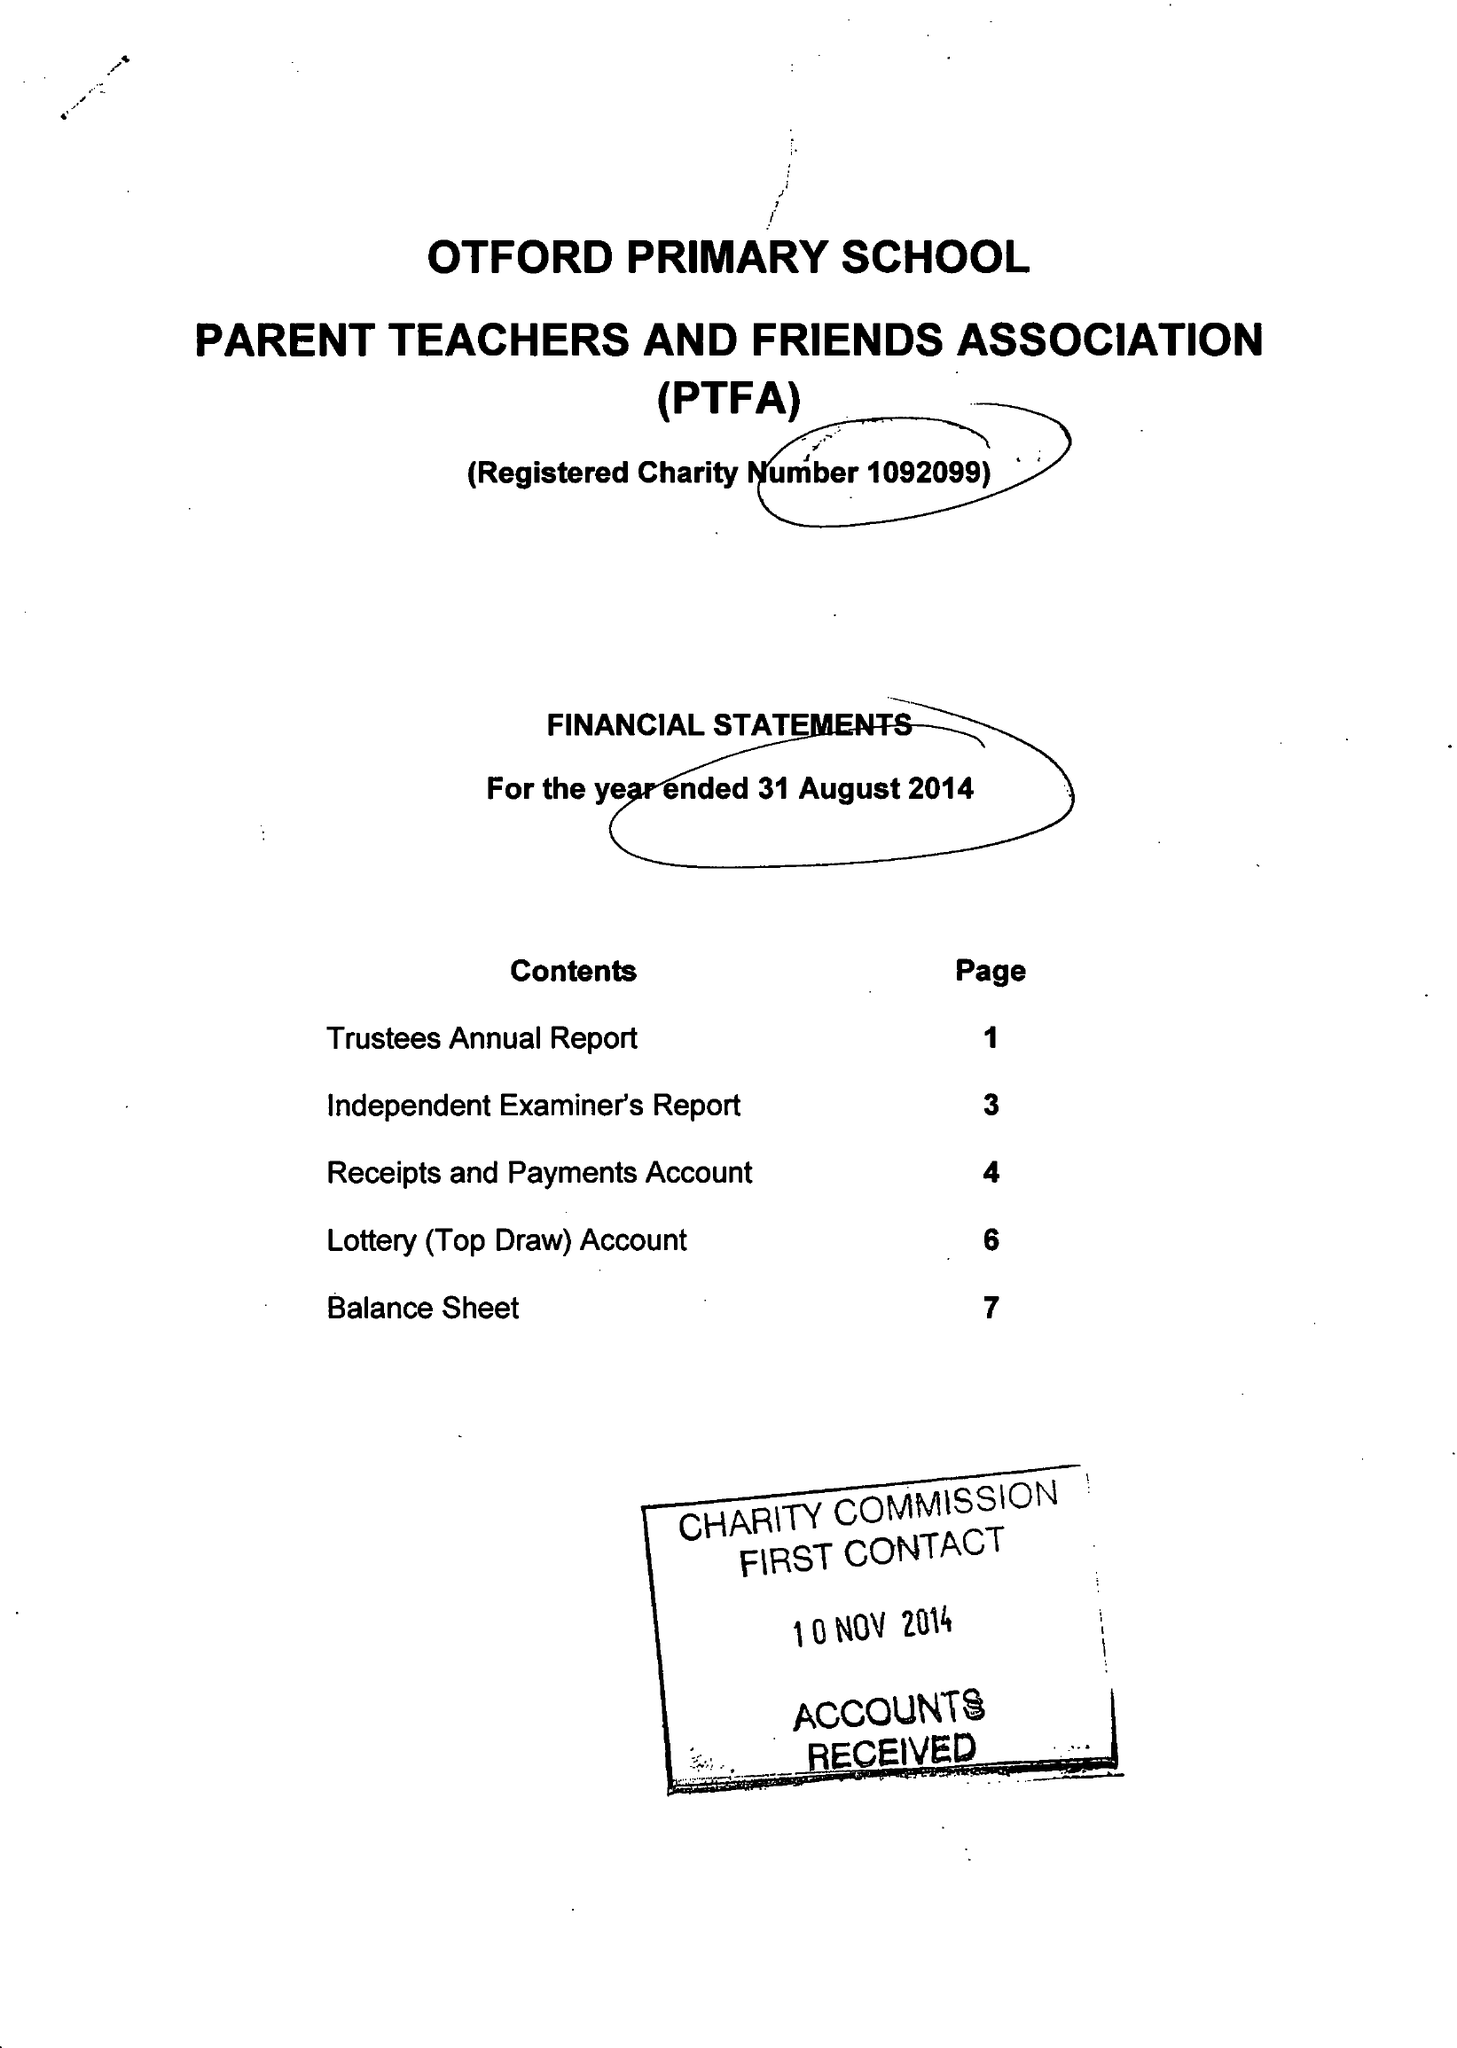What is the value for the spending_annually_in_british_pounds?
Answer the question using a single word or phrase. 52945.00 